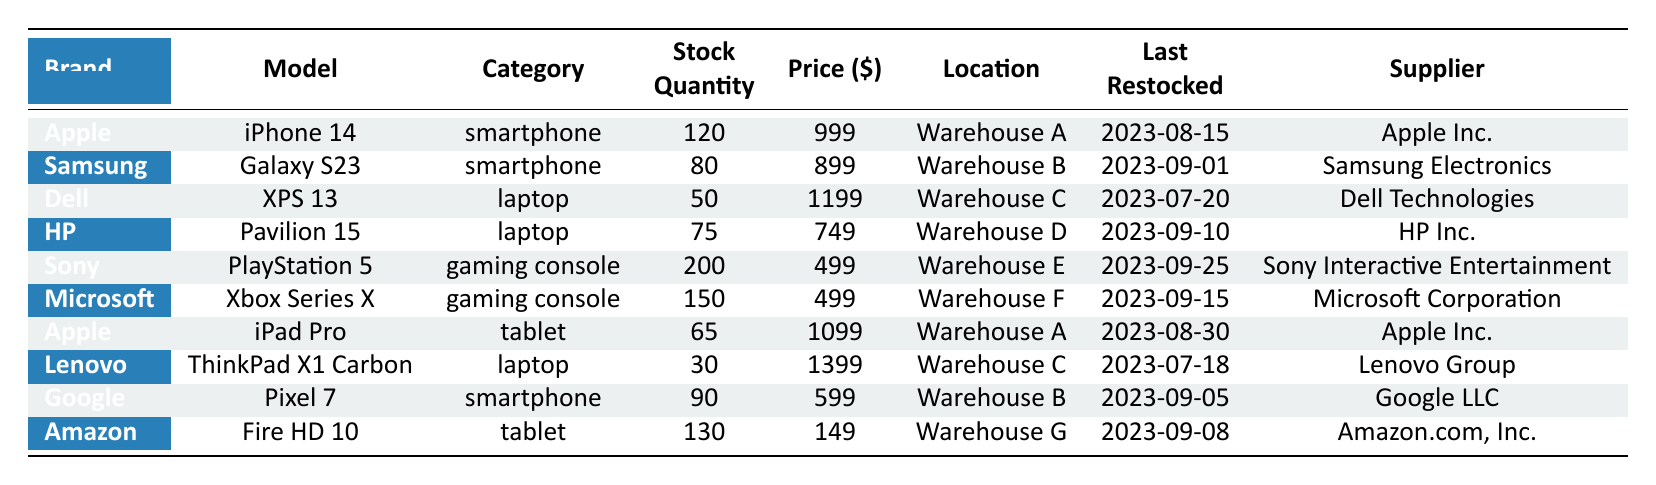What is the stock quantity of the Samsung Galaxy S23? The stock quantity for the Samsung Galaxy S23 is provided directly in the table under the stock quantity column. It shows a value of 80.
Answer: 80 How many laptops are listed in total? From the table, we can see that there are four models categorized under laptops: Dell XPS 13, HP Pavilion 15, Lenovo ThinkPad X1 Carbon, and two Apple models. Therefore, the total number is 4.
Answer: 4 Which brand has the highest stock quantity? By examining the stock quantities for each brand, we determine that the Sony PlayStation 5 has the highest stock quantity of 200, compared to all other devices.
Answer: Sony Is the Apple iPad Pro cheaper than the Google Pixel 7? The price of the Apple iPad Pro is listed as 1099 while the price of the Google Pixel 7 is listed as 599. Therefore, it is false that the iPad Pro is cheaper than the Pixel 7.
Answer: No What is the total stock quantity of tablets available? From the table, there are two tablet models: Apple iPad Pro with 65 in stock and Amazon Fire HD 10 with 130 in stock. Summing these yields 65 + 130 = 195.
Answer: 195 Which warehouse has the highest number of devices in stock? There are several warehouses listed, and the stock quantities are: Warehouse A has 120 (iPhone 14) + 65 (iPad Pro) = 185, Warehouse B has 80 (Galaxy S23) + 90 (Pixel 7) = 170, Warehouse C has 50 (XPS 13) + 30 (ThinkPad) = 80, Warehouse D has 75 (Pavilion 15), Warehouse E has 200 (PlayStation 5), Warehouse F has 150 (Xbox Series X), and Warehouse G has 130 (Fire HD 10). The maximum total is 200 at Warehouse E.
Answer: Warehouse E How many devices are located in Warehouse A? There are two devices located in Warehouse A: the Apple iPhone 14 (120 units) and the Apple iPad Pro (65 units). Hence, 120 + 65 = 185 units.
Answer: 185 Was the Microsoft Xbox Series X restocked before the Samsung Galaxy S23? The last restocked date for the Xbox Series X is September 15, 2023, and for the Galaxy S23, it's September 1, 2023. Since September 15 is later than September 1, the statement is false.
Answer: No 